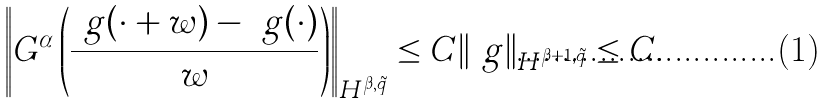<formula> <loc_0><loc_0><loc_500><loc_500>\left \| G ^ { \alpha } \left ( \frac { \ g ( \cdot + w ) - \ g ( \cdot ) } { w } \right ) \right \| _ { H ^ { \beta , \tilde { q } } } \leq C \| \ g \| _ { H ^ { \beta + 1 , \tilde { q } } } \leq C .</formula> 